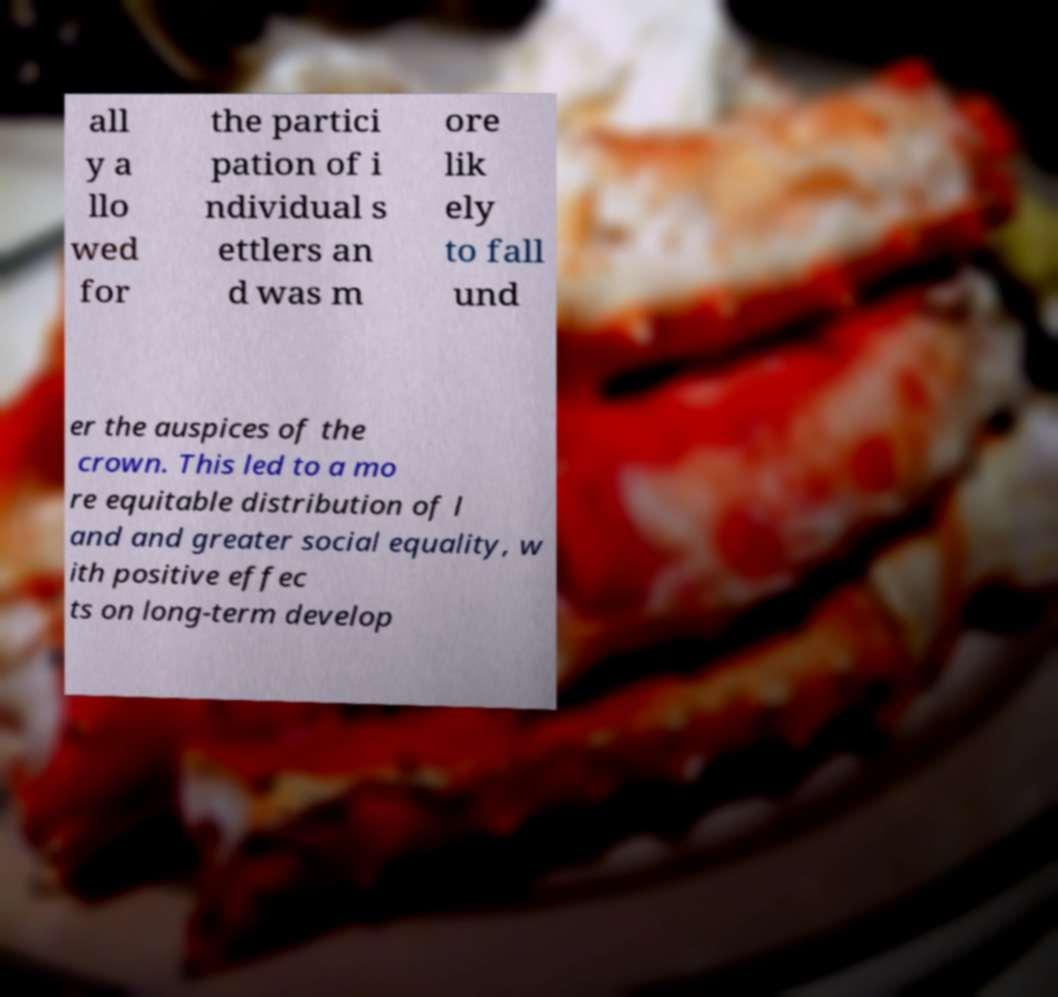What messages or text are displayed in this image? I need them in a readable, typed format. all y a llo wed for the partici pation of i ndividual s ettlers an d was m ore lik ely to fall und er the auspices of the crown. This led to a mo re equitable distribution of l and and greater social equality, w ith positive effec ts on long-term develop 